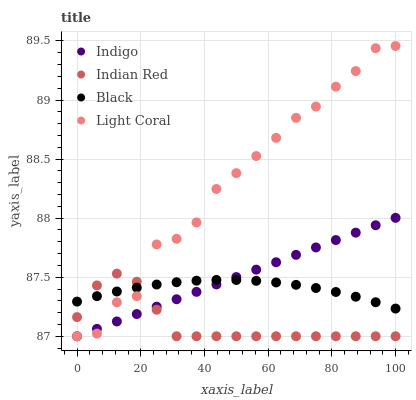Does Indian Red have the minimum area under the curve?
Answer yes or no. Yes. Does Light Coral have the maximum area under the curve?
Answer yes or no. Yes. Does Black have the minimum area under the curve?
Answer yes or no. No. Does Black have the maximum area under the curve?
Answer yes or no. No. Is Indigo the smoothest?
Answer yes or no. Yes. Is Light Coral the roughest?
Answer yes or no. Yes. Is Black the smoothest?
Answer yes or no. No. Is Black the roughest?
Answer yes or no. No. Does Light Coral have the lowest value?
Answer yes or no. Yes. Does Black have the lowest value?
Answer yes or no. No. Does Light Coral have the highest value?
Answer yes or no. Yes. Does Indigo have the highest value?
Answer yes or no. No. Does Black intersect Indian Red?
Answer yes or no. Yes. Is Black less than Indian Red?
Answer yes or no. No. Is Black greater than Indian Red?
Answer yes or no. No. 